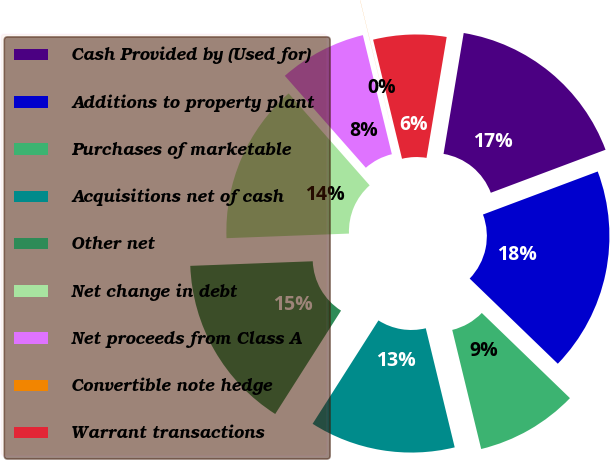<chart> <loc_0><loc_0><loc_500><loc_500><pie_chart><fcel>Cash Provided by (Used for)<fcel>Additions to property plant<fcel>Purchases of marketable<fcel>Acquisitions net of cash<fcel>Other net<fcel>Net change in debt<fcel>Net proceeds from Class A<fcel>Convertible note hedge<fcel>Warrant transactions<nl><fcel>16.66%<fcel>17.94%<fcel>8.98%<fcel>12.82%<fcel>15.38%<fcel>14.1%<fcel>7.7%<fcel>0.01%<fcel>6.42%<nl></chart> 